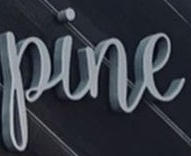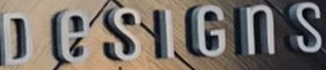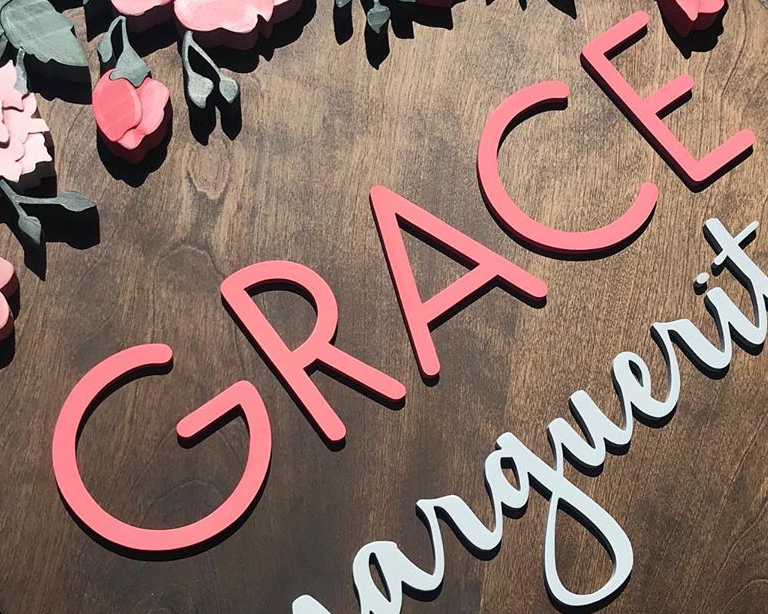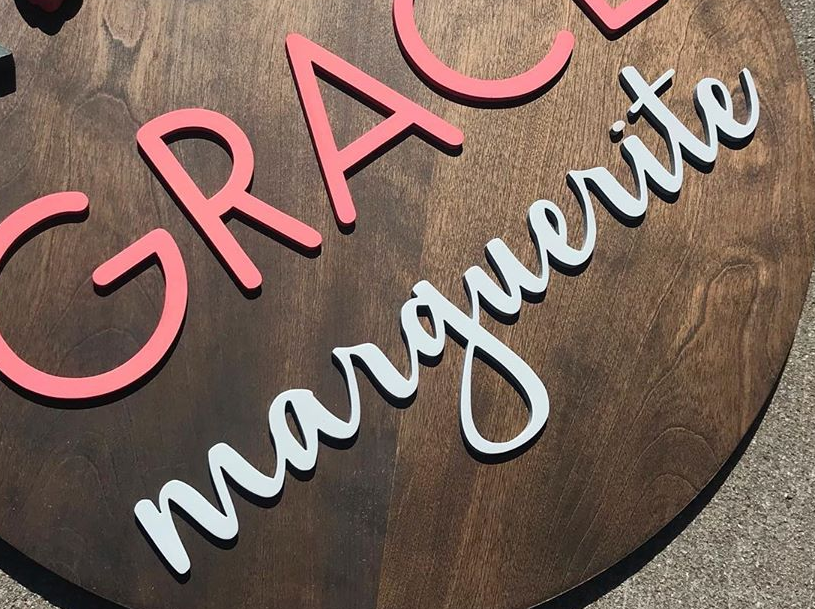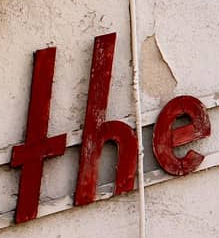Transcribe the words shown in these images in order, separated by a semicolon. pine; DeSIGnS; GRACE; marguerite; THE 